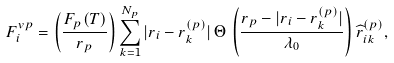<formula> <loc_0><loc_0><loc_500><loc_500>F _ { i } ^ { v p } = \left ( \frac { F _ { p } ( T ) } { r _ { p } } \right ) \sum _ { k = 1 } ^ { N _ { p } } | r _ { i } - r _ { k } ^ { ( p ) } | \, \Theta \, \left ( \frac { r _ { p } - | r _ { i } - r _ { k } ^ { ( p ) } | } { \lambda _ { 0 } } \right ) \widehat { r } _ { i k } ^ { ( p ) } ,</formula> 